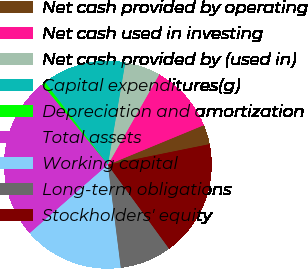Convert chart. <chart><loc_0><loc_0><loc_500><loc_500><pie_chart><fcel>Net cash provided by operating<fcel>Net cash used in investing<fcel>Net cash provided by (used in)<fcel>Capital expenditures(g)<fcel>Depreciation and amortization<fcel>Total assets<fcel>Working capital<fcel>Long-term obligations<fcel>Stockholders' equity<nl><fcel>3.05%<fcel>10.54%<fcel>5.54%<fcel>13.04%<fcel>0.55%<fcel>25.54%<fcel>15.54%<fcel>8.04%<fcel>18.15%<nl></chart> 